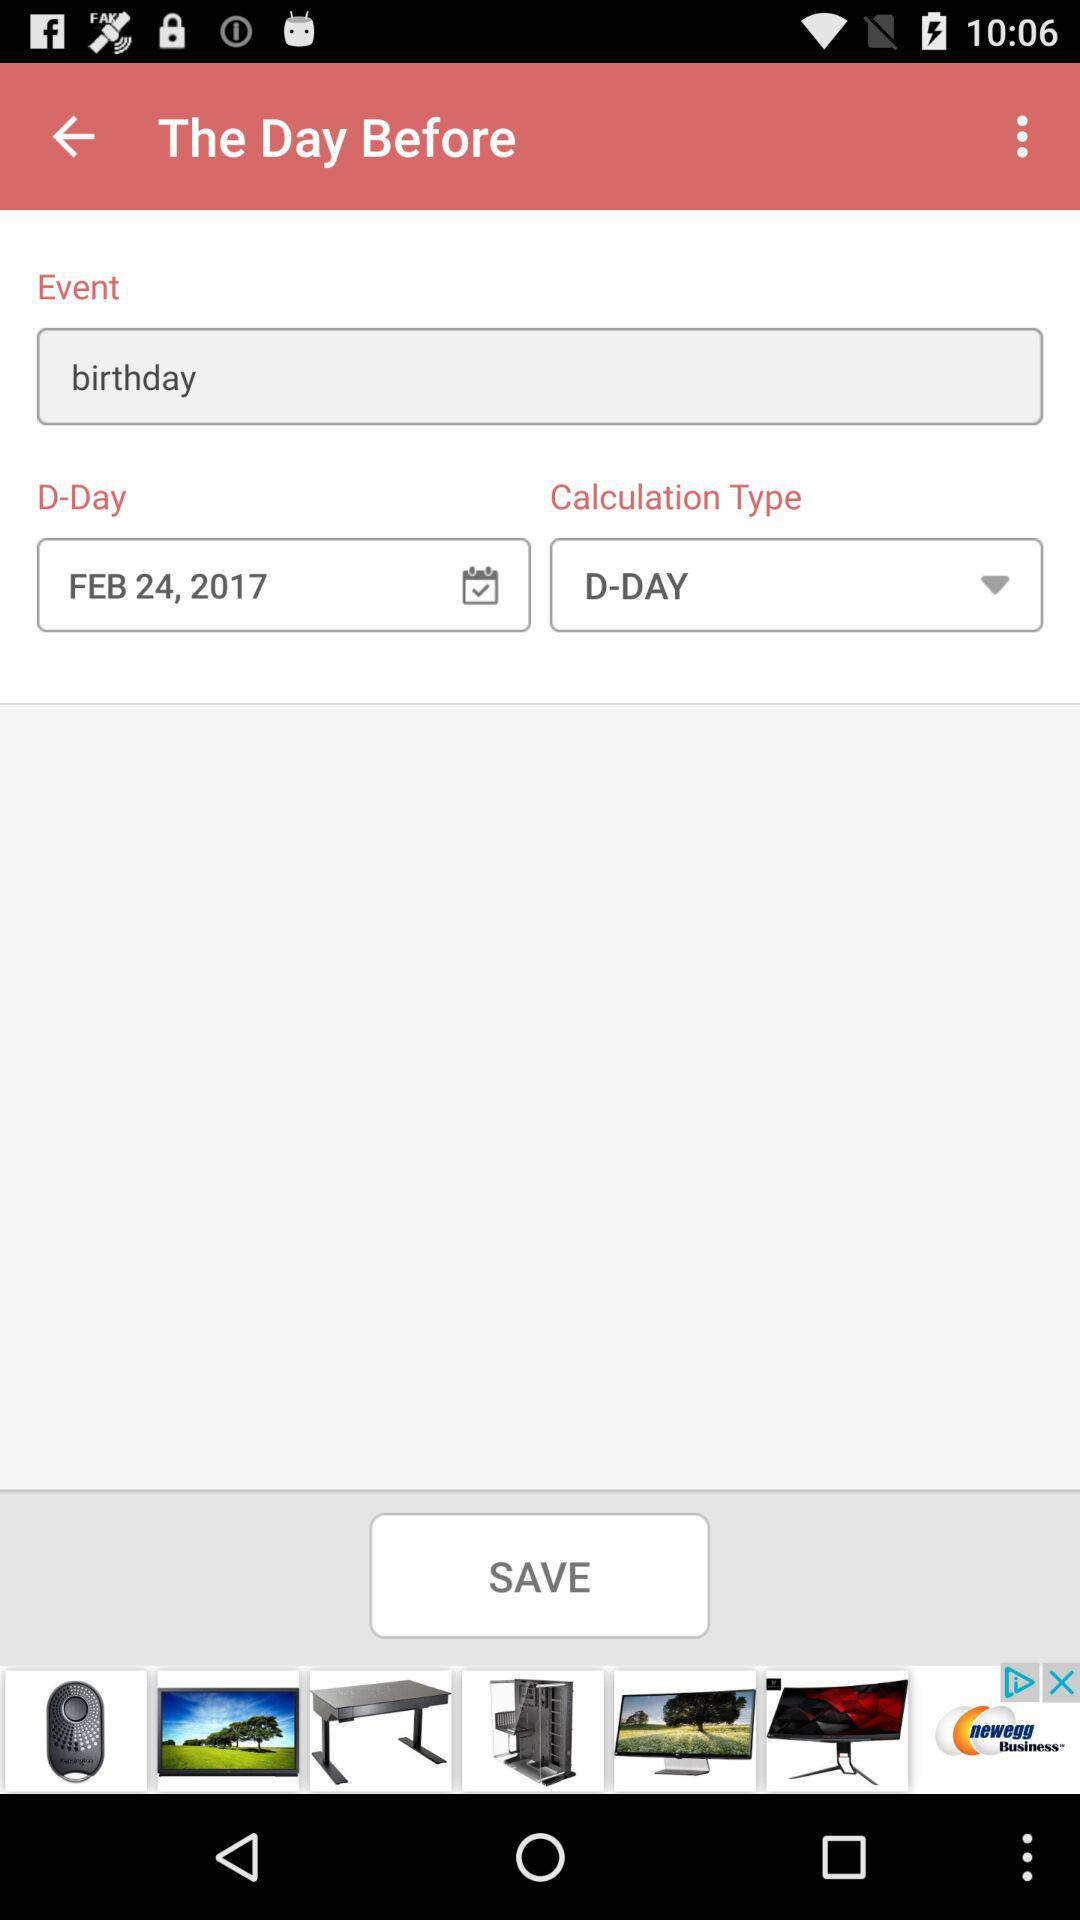What is the birthday date? The birthday date is February 24, 2017. 